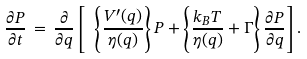Convert formula to latex. <formula><loc_0><loc_0><loc_500><loc_500>\frac { \partial P } { \partial t } \, = \, \frac { \partial } { \partial q } \left [ \ \left \{ \frac { V ^ { \prime } ( q ) } { \eta ( q ) } \right \} P + \left \{ \frac { k _ { B } T } { \eta ( q ) } + \Gamma \right \} \frac { \partial P } { \partial q } \right ] .</formula> 